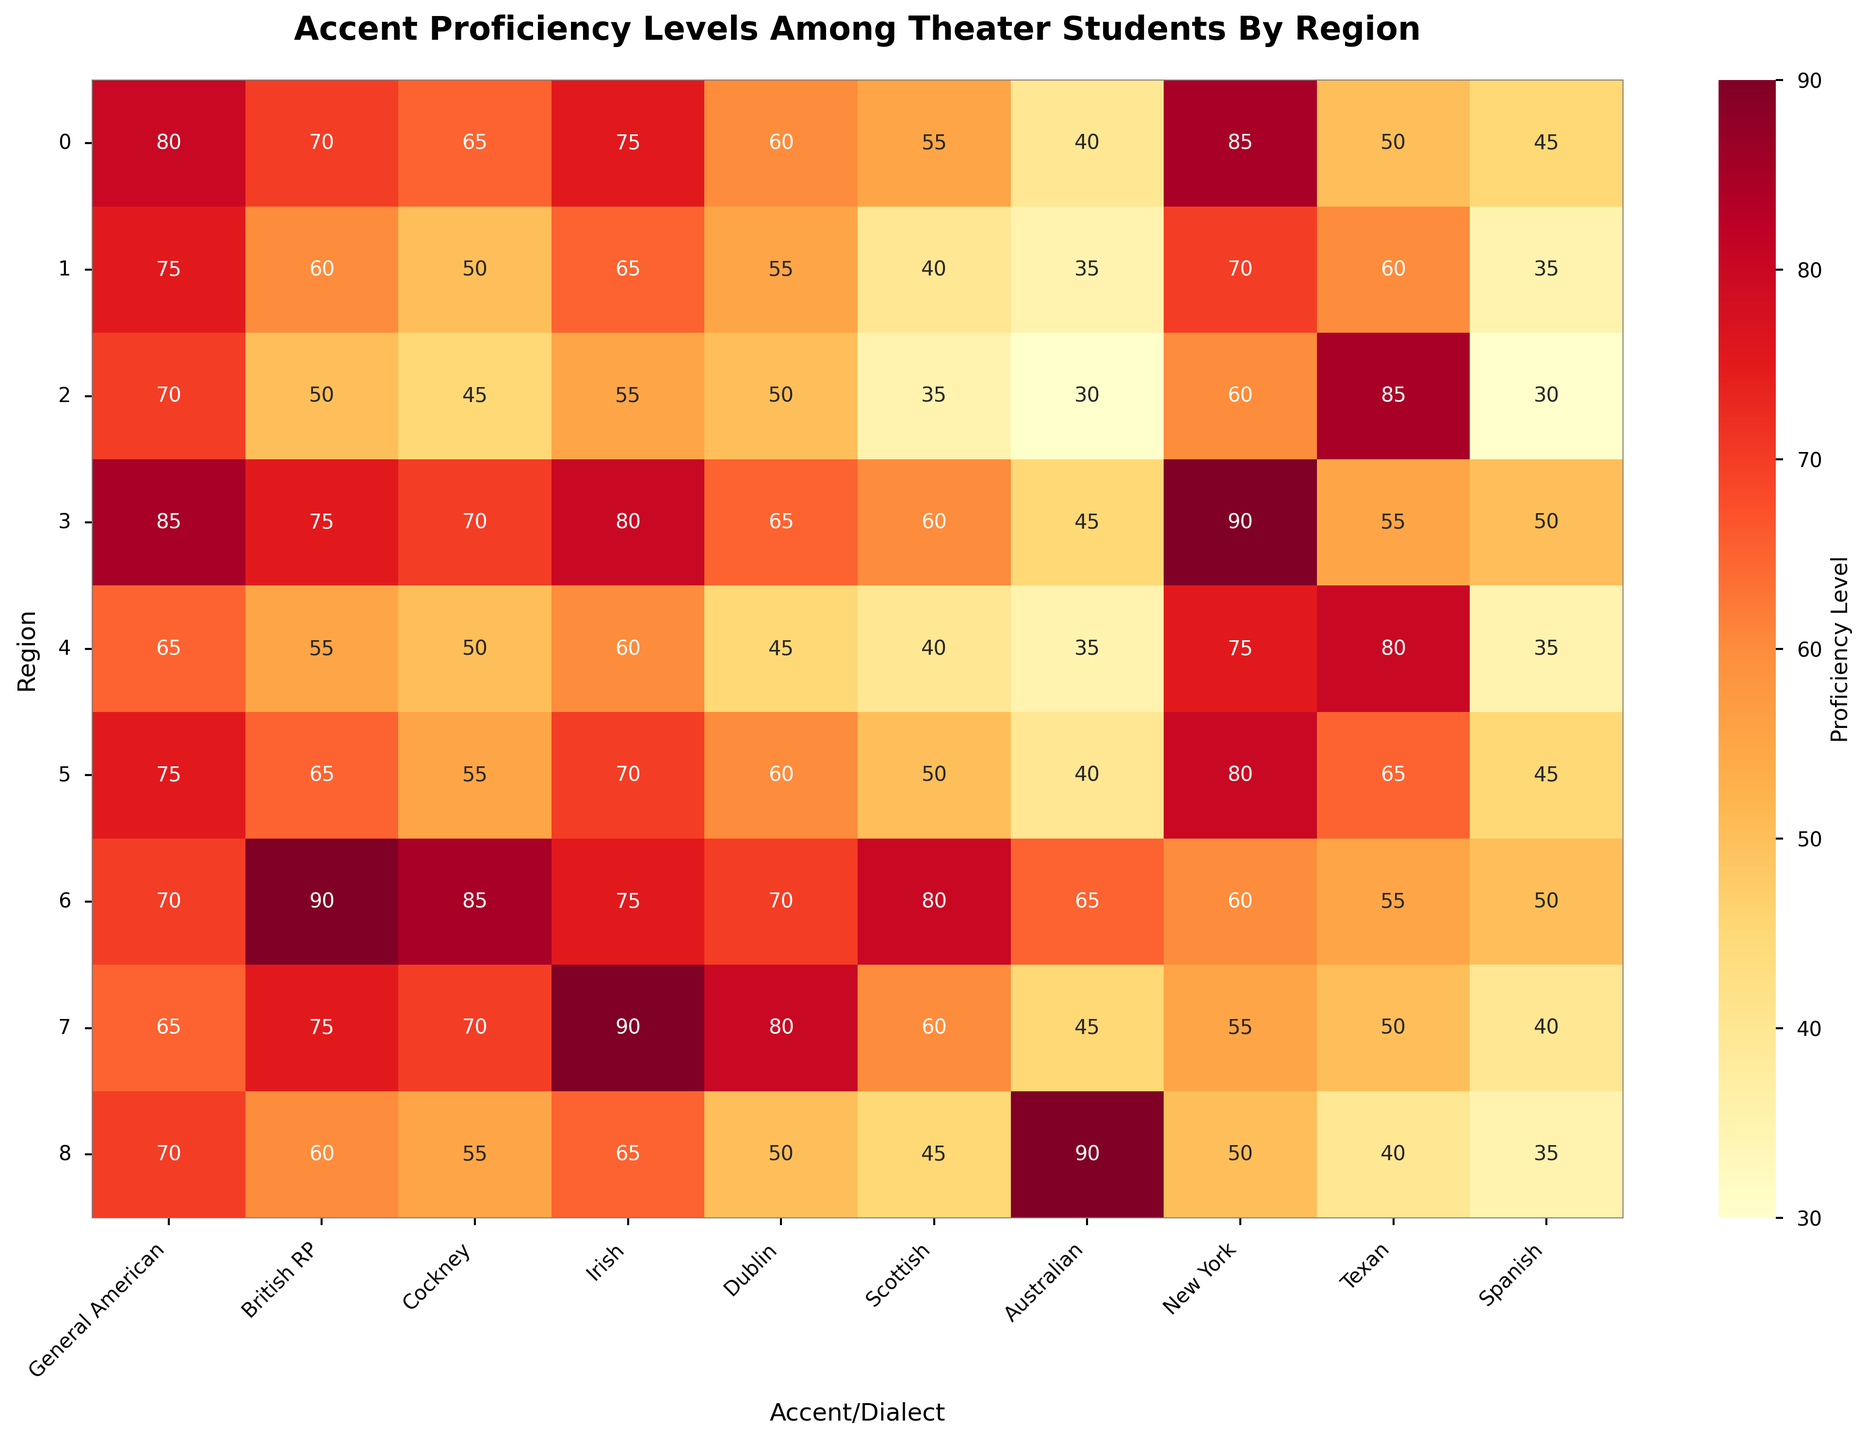What is the proficiency level of Northeast USA students in General American accent? Look at the heatmap cell where the row is "Northeast USA" and the column is "General American". The value in this cell represents the proficiency level.
Answer: 80 Which region shows the highest proficiency in the British RP accent? Identify the column for "British RP" and locate the cell with the highest value in that column.
Answer: United Kingdom What is the average proficiency level of West Coast USA students across all accents? Sum the proficiency levels for West Coast USA across all accents (85 + 75 + 70 + 80 + 65 + 60 + 45 + 90 + 55 + 50) and divide by the number of accents (10). The sum is 675, and the average is 675/10.
Answer: 67.5 Are Midwest USA students more proficient in the Texan or Spanish accent? Compare the proficiency values for Midwest USA in the "Texan" and "Spanish" columns. Texan is 60 and Spanish is 35, so Texan is higher.
Answer: Texan Which region has the lowest proficiency in the Scottish accent? Identify the column for "Scottish" and locate the cell with the lowest value in that column.
Answer: South USA What are the three accents with the highest proficiency levels for students in Ireland? Look at the values in the "Ireland" row. The highest values are 90 (Irish), 80 (Dublin), and 75 (British RP).
Answer: Irish, Dublin, British RP Do United Kingdom students score equally high in Cockney and General American accents? Compare the proficiency levels for "Cockney" and "General American" in the United Kingdom row. Cockney is 85 and General American is 70.
Answer: No What is the difference in proficiency levels in the New York accent between Northeast USA and Southwest USA? Find the values for "New York" in the rows for Northeast USA (85) and Southwest USA (80), and calculate the difference 85 - 80.
Answer: 5 Which region has the closest proficiency levels for Texan and New York accents? Compare the difference between the "Texan" and "New York" columns for all regions. The closest difference is for Southeast USA (80-75=5).
Answer: Southeast USA 